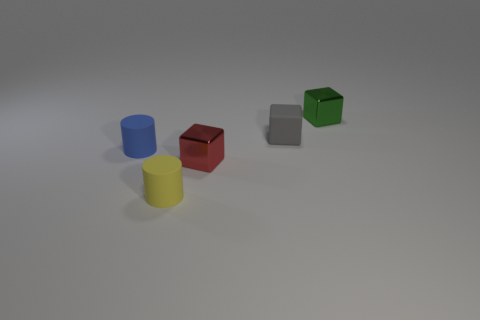Is there a gray cube that has the same material as the small yellow cylinder?
Make the answer very short. Yes. What color is the small matte cube?
Your answer should be very brief. Gray. There is a metallic object on the left side of the tiny metal block behind the shiny thing on the left side of the green metal thing; how big is it?
Your answer should be compact. Small. What number of other things are there of the same shape as the small red object?
Make the answer very short. 2. What color is the tiny object that is on the left side of the tiny red metallic block and in front of the blue cylinder?
Make the answer very short. Yellow. What number of spheres are either blue objects or red metal things?
Your answer should be compact. 0. The matte thing that is right of the red object has what shape?
Your answer should be very brief. Cube. What color is the matte object to the left of the small yellow rubber thing that is left of the shiny object that is on the left side of the gray thing?
Your answer should be very brief. Blue. Is the material of the yellow cylinder the same as the green thing?
Provide a succinct answer. No. How many purple objects are either tiny rubber blocks or matte cylinders?
Your answer should be compact. 0. 